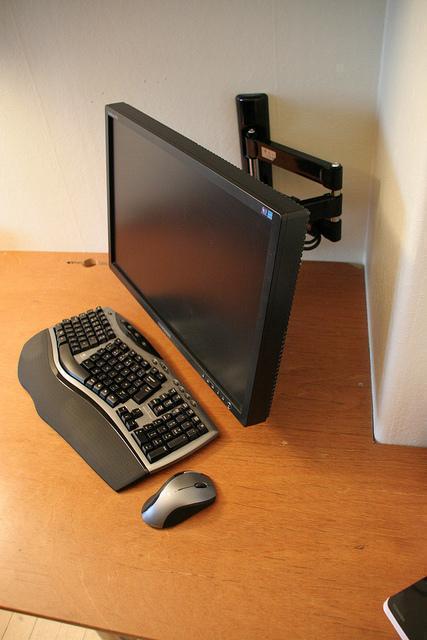What is the mouse next to?
Indicate the correct response and explain using: 'Answer: answer
Rationale: rationale.'
Options: Cat, goat, keyboard, cherry. Answer: keyboard.
Rationale: The mouse is beside the keyboard on the desk. 